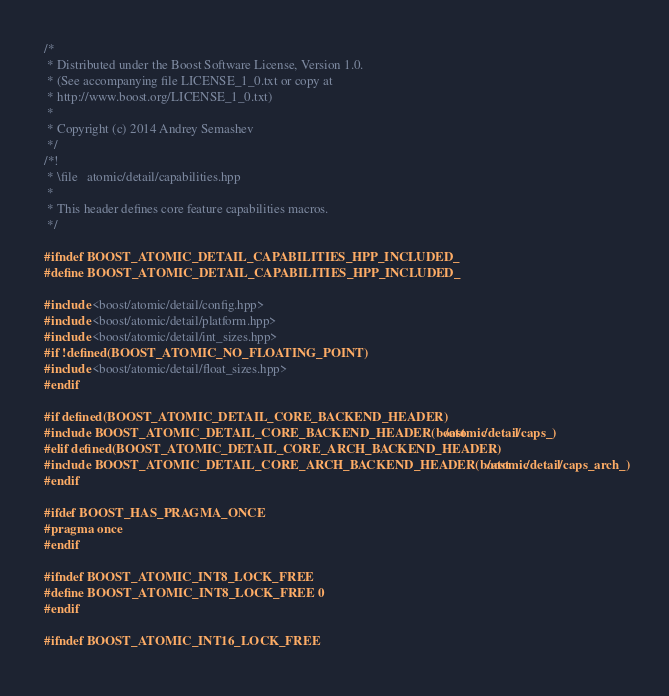Convert code to text. <code><loc_0><loc_0><loc_500><loc_500><_C++_>/*
 * Distributed under the Boost Software License, Version 1.0.
 * (See accompanying file LICENSE_1_0.txt or copy at
 * http://www.boost.org/LICENSE_1_0.txt)
 *
 * Copyright (c) 2014 Andrey Semashev
 */
/*!
 * \file   atomic/detail/capabilities.hpp
 *
 * This header defines core feature capabilities macros.
 */

#ifndef BOOST_ATOMIC_DETAIL_CAPABILITIES_HPP_INCLUDED_
#define BOOST_ATOMIC_DETAIL_CAPABILITIES_HPP_INCLUDED_

#include <boost/atomic/detail/config.hpp>
#include <boost/atomic/detail/platform.hpp>
#include <boost/atomic/detail/int_sizes.hpp>
#if !defined(BOOST_ATOMIC_NO_FLOATING_POINT)
#include <boost/atomic/detail/float_sizes.hpp>
#endif

#if defined(BOOST_ATOMIC_DETAIL_CORE_BACKEND_HEADER)
#include BOOST_ATOMIC_DETAIL_CORE_BACKEND_HEADER(boost/atomic/detail/caps_)
#elif defined(BOOST_ATOMIC_DETAIL_CORE_ARCH_BACKEND_HEADER)
#include BOOST_ATOMIC_DETAIL_CORE_ARCH_BACKEND_HEADER(boost/atomic/detail/caps_arch_)
#endif

#ifdef BOOST_HAS_PRAGMA_ONCE
#pragma once
#endif

#ifndef BOOST_ATOMIC_INT8_LOCK_FREE
#define BOOST_ATOMIC_INT8_LOCK_FREE 0
#endif

#ifndef BOOST_ATOMIC_INT16_LOCK_FREE</code> 